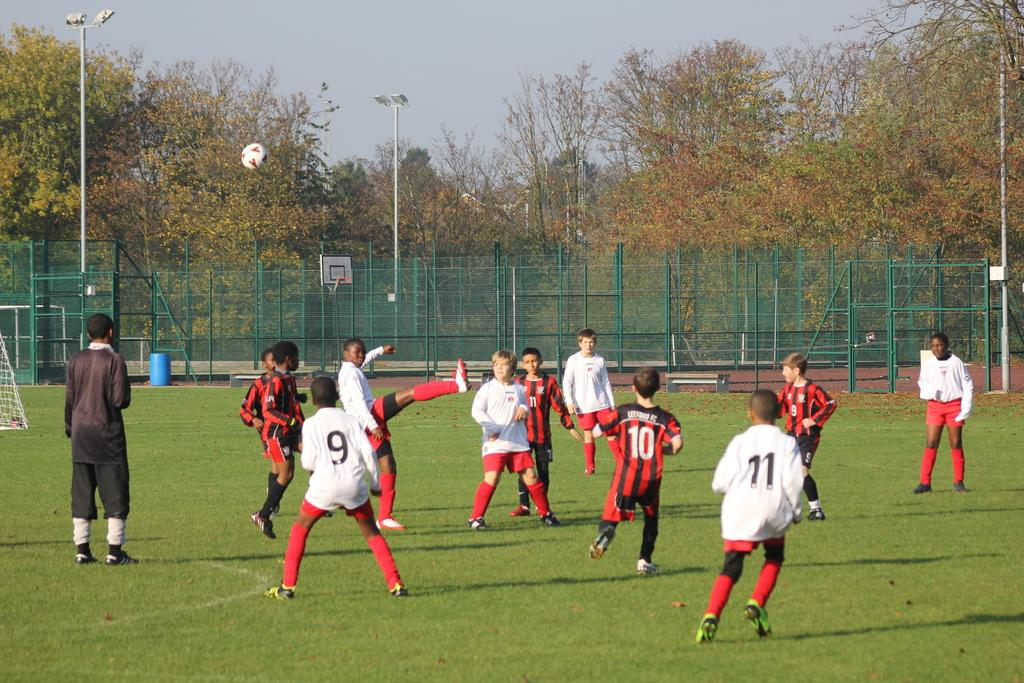<image>
Describe the image concisely. Several soccer players, including jersey numbers 9 and 11, are playing. 